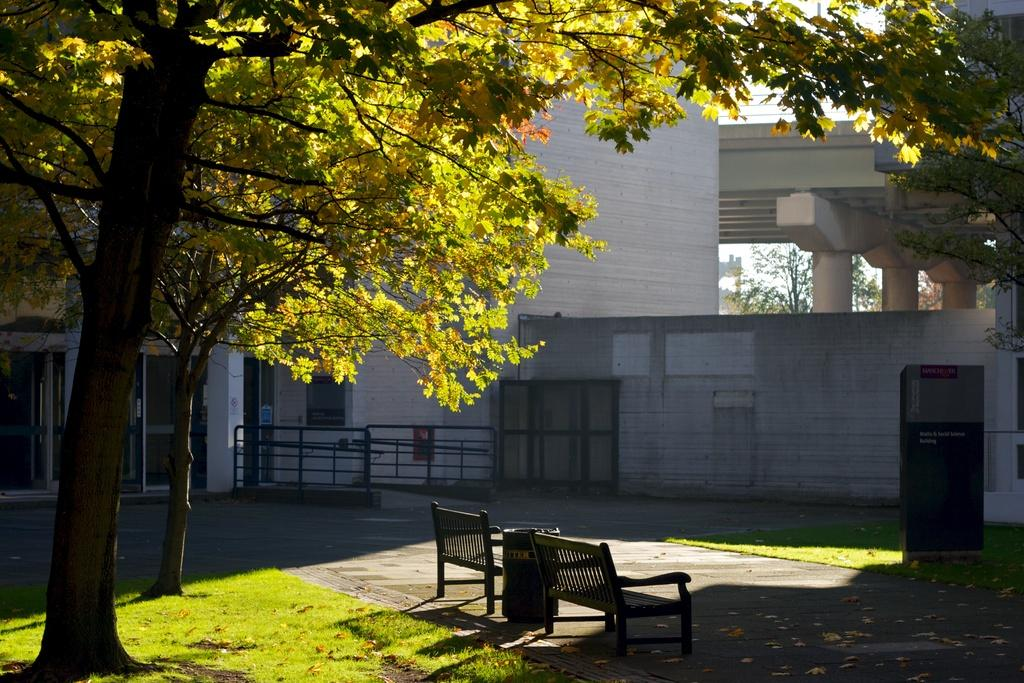What type of vegetation can be seen in the image? There are trees and grass in the image. What type of seating is available in the image? There are wooden benches in the image. What is used for waste disposal in the image? There is a dustbin in the image. What is used to enclose or separate areas in the image? There is a fence in the image. What type of structure is visible in the image? There is a building in the image. What can be seen in the background of the image? The sky is visible in the background of the image. How many sheep are grazing on the grass in the image? There are no sheep present in the image. What type of material is used to support the building in the image? The building's support structure is not visible in the image, so it cannot be determined from the image. 